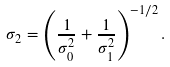<formula> <loc_0><loc_0><loc_500><loc_500>\sigma _ { 2 } = \left ( \frac { 1 } { \sigma _ { 0 } ^ { 2 } } + \frac { 1 } { \sigma _ { 1 } ^ { 2 } } \right ) ^ { - 1 / 2 } .</formula> 